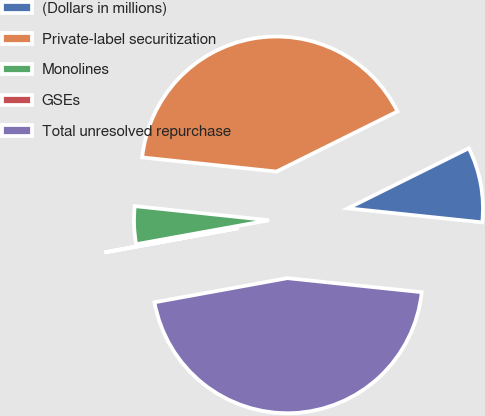<chart> <loc_0><loc_0><loc_500><loc_500><pie_chart><fcel>(Dollars in millions)<fcel>Private-label securitization<fcel>Monolines<fcel>GSEs<fcel>Total unresolved repurchase<nl><fcel>9.0%<fcel>40.99%<fcel>4.51%<fcel>0.02%<fcel>45.48%<nl></chart> 